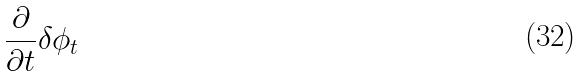<formula> <loc_0><loc_0><loc_500><loc_500>\frac { \partial } { \partial t } \delta \phi _ { t }</formula> 